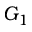Convert formula to latex. <formula><loc_0><loc_0><loc_500><loc_500>G _ { 1 }</formula> 